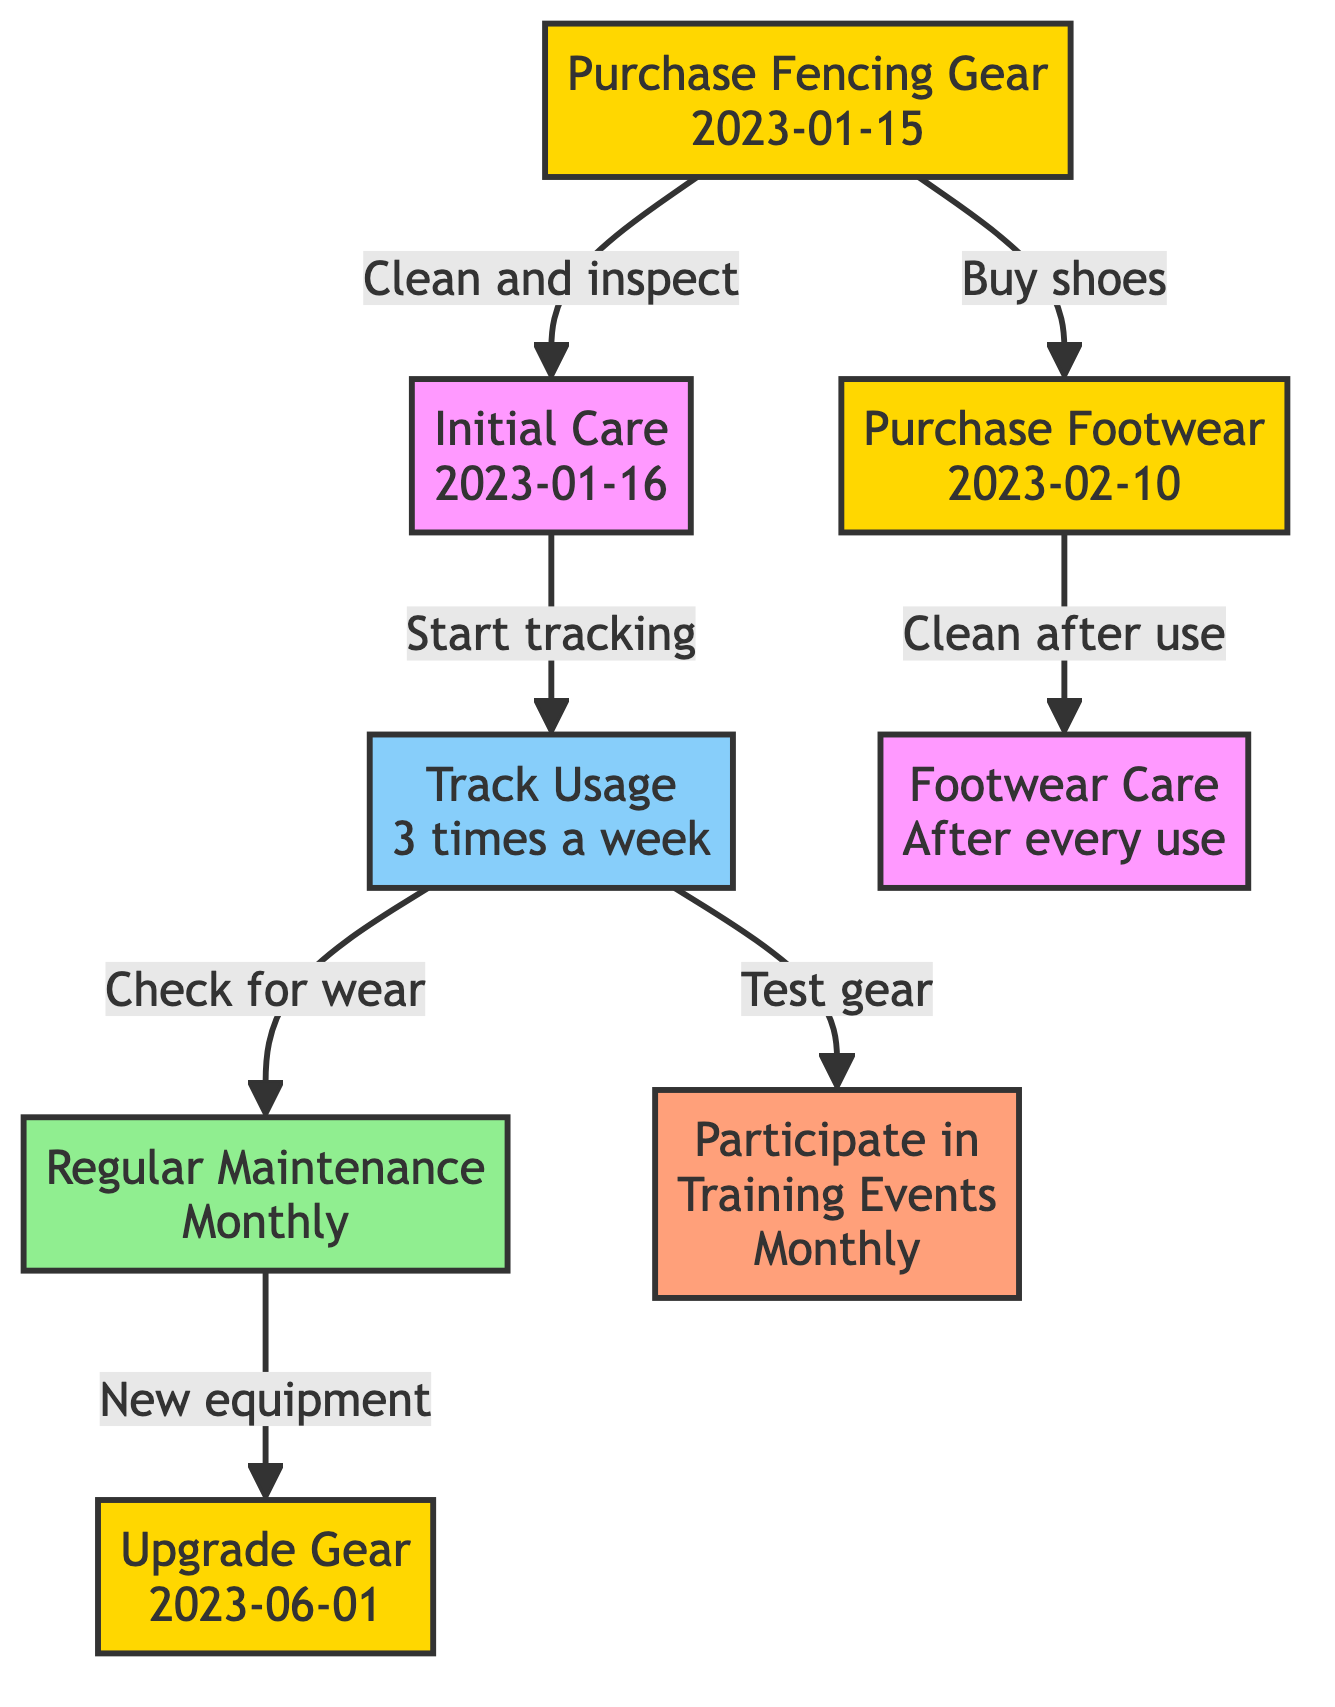What's the date of the fencing gear purchase? The diagram indicates the purchase of fencing gear took place on January 15, 2023. This date is provided in the "Purchase" node, which contains the action of purchasing gear and the respective date.
Answer: January 15, 2023 Which action follows the "Initial Care"? Following the "Initial Care" node, the next node is "Track Usage." The edge leading from "Initial Care" to "Track Usage" implies that usage tracking begins after the initial care actions are completed.
Answer: Track Usage How often is regular maintenance scheduled? The "Regular Maintenance" node specifies that maintenance occurs monthly, as indicated by the details contained within that node.
Answer: Monthly How many nodes are in the diagram? By counting the items listed under the "nodes" section of the data, we can determine that there are eight unique nodes in total.
Answer: 8 What connects "UsageTracking" to "EventParticipation"? In the diagram, the "UsageTracking" node has a directed edge leading to "EventParticipation," signifying that tracking usage triggers participation in training events.
Answer: Test gear What items were upgraded on June 1, 2023? The "Upgrade Gear" node outlines the items upgraded, specifically a "New Electric Foil" and a "Body Cord." This information is directly stated in the details of that node.
Answer: New Electric Foil, Body Cord What frequency should footwear be cleaned? According to the "Footwear Care" node, footwear must be cleaned after each use, as stated in its details.
Answer: After every use What action is taken after purchasing footwear? After purchasing footwear, the next action is "Footwear Care," as indicated by the directed edge linking "ShoePurchase" to "ShoeCare." This signifies a chain of actions starting from the purchase.
Answer: Footwear Care 